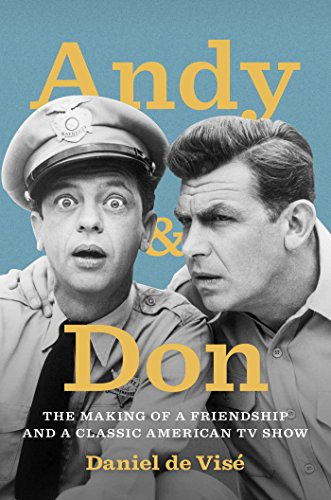What might this book reveal about the relationship between the two individuals depicted? This book likely delves into the deep friendship and remarkable collaboration between Andy Griffith and Don Knotts, reflecting on how their off-screen bond translated to on-screen chemistry, contributing to the show's success and their lasting legacies in American entertainment. 